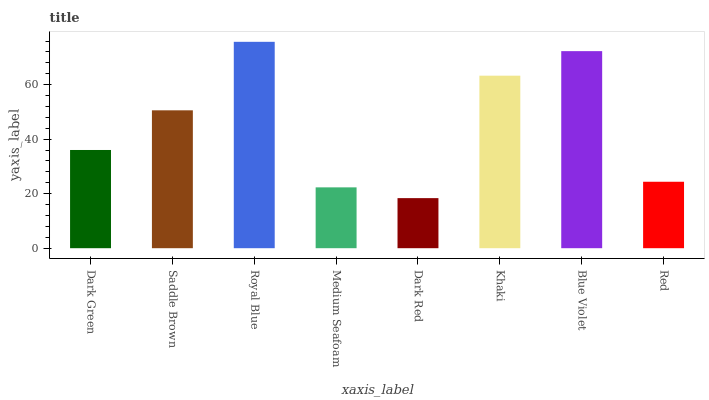Is Dark Red the minimum?
Answer yes or no. Yes. Is Royal Blue the maximum?
Answer yes or no. Yes. Is Saddle Brown the minimum?
Answer yes or no. No. Is Saddle Brown the maximum?
Answer yes or no. No. Is Saddle Brown greater than Dark Green?
Answer yes or no. Yes. Is Dark Green less than Saddle Brown?
Answer yes or no. Yes. Is Dark Green greater than Saddle Brown?
Answer yes or no. No. Is Saddle Brown less than Dark Green?
Answer yes or no. No. Is Saddle Brown the high median?
Answer yes or no. Yes. Is Dark Green the low median?
Answer yes or no. Yes. Is Blue Violet the high median?
Answer yes or no. No. Is Khaki the low median?
Answer yes or no. No. 